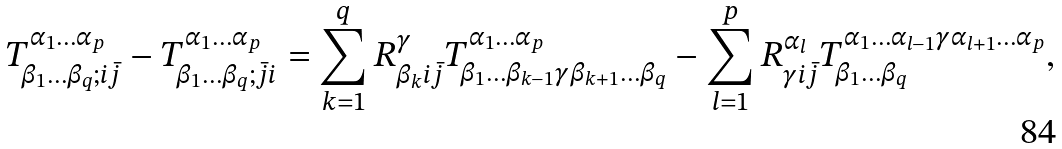<formula> <loc_0><loc_0><loc_500><loc_500>T _ { \beta _ { 1 } \dots \beta _ { q } ; i \bar { j } } ^ { \alpha _ { 1 } \dots \alpha _ { p } } - T _ { \beta _ { 1 } \dots \beta _ { q } ; \bar { j } i } ^ { \alpha _ { 1 } \dots \alpha _ { p } } = \sum _ { k = 1 } ^ { q } R _ { \beta _ { k } i \bar { j } } ^ { \gamma } T _ { \beta _ { 1 } \dots \beta _ { k - 1 } \gamma \beta _ { k + 1 } \dots \beta _ { q } } ^ { \alpha _ { 1 } \dots \alpha _ { p } } - \sum _ { l = 1 } ^ { p } R _ { \gamma i \bar { j } } ^ { \alpha _ { l } } T _ { \beta _ { 1 } \dots \beta _ { q } } ^ { \alpha _ { 1 } \dots \alpha _ { l - 1 } \gamma \alpha _ { l + 1 } \dots \alpha _ { p } } ,</formula> 